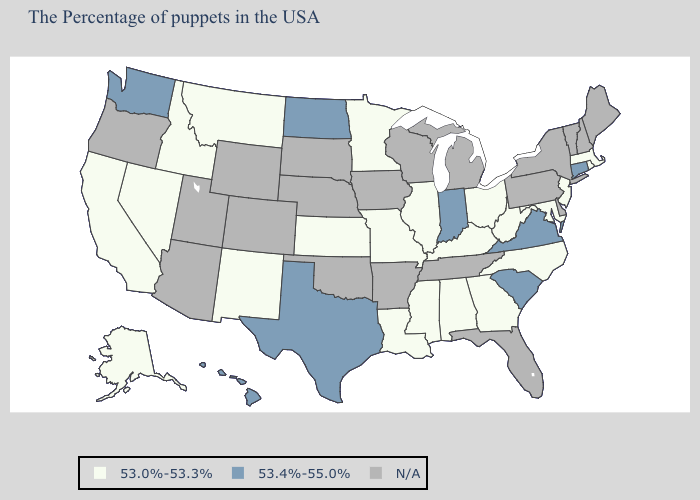Does Virginia have the lowest value in the South?
Give a very brief answer. No. What is the lowest value in states that border Kansas?
Quick response, please. 53.0%-53.3%. What is the value of Massachusetts?
Write a very short answer. 53.0%-53.3%. Name the states that have a value in the range N/A?
Give a very brief answer. Maine, New Hampshire, Vermont, New York, Delaware, Pennsylvania, Florida, Michigan, Tennessee, Wisconsin, Arkansas, Iowa, Nebraska, Oklahoma, South Dakota, Wyoming, Colorado, Utah, Arizona, Oregon. Among the states that border New York , does New Jersey have the lowest value?
Give a very brief answer. Yes. Name the states that have a value in the range 53.0%-53.3%?
Quick response, please. Massachusetts, Rhode Island, New Jersey, Maryland, North Carolina, West Virginia, Ohio, Georgia, Kentucky, Alabama, Illinois, Mississippi, Louisiana, Missouri, Minnesota, Kansas, New Mexico, Montana, Idaho, Nevada, California, Alaska. Name the states that have a value in the range 53.0%-53.3%?
Write a very short answer. Massachusetts, Rhode Island, New Jersey, Maryland, North Carolina, West Virginia, Ohio, Georgia, Kentucky, Alabama, Illinois, Mississippi, Louisiana, Missouri, Minnesota, Kansas, New Mexico, Montana, Idaho, Nevada, California, Alaska. Does Virginia have the highest value in the USA?
Concise answer only. Yes. Does Alaska have the highest value in the West?
Write a very short answer. No. Among the states that border California , which have the lowest value?
Concise answer only. Nevada. What is the lowest value in the USA?
Give a very brief answer. 53.0%-53.3%. What is the value of Oklahoma?
Concise answer only. N/A. What is the value of Nevada?
Keep it brief. 53.0%-53.3%. Does California have the highest value in the West?
Short answer required. No. 